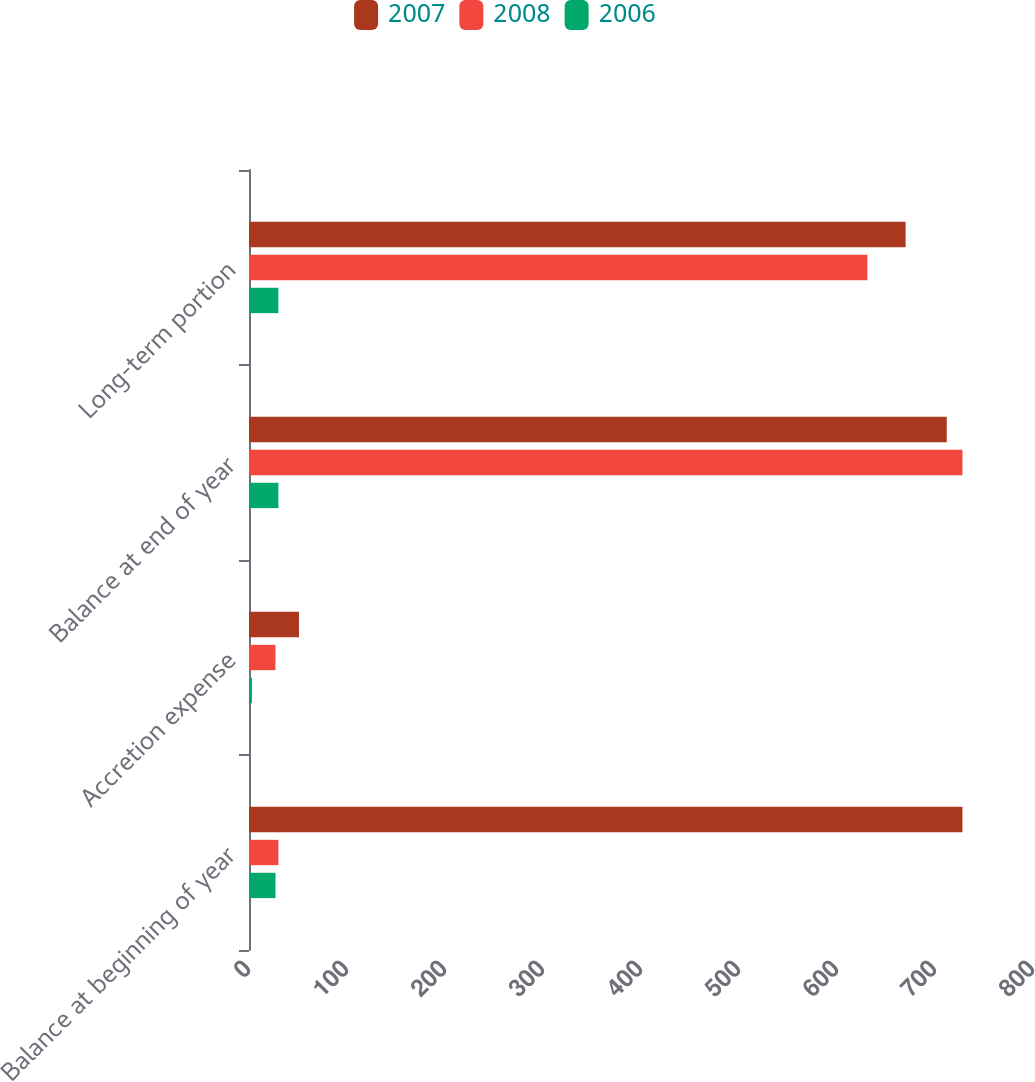<chart> <loc_0><loc_0><loc_500><loc_500><stacked_bar_chart><ecel><fcel>Balance at beginning of year<fcel>Accretion expense<fcel>Balance at end of year<fcel>Long-term portion<nl><fcel>2007<fcel>728<fcel>51<fcel>712<fcel>670<nl><fcel>2008<fcel>30<fcel>27<fcel>728<fcel>631<nl><fcel>2006<fcel>27<fcel>3<fcel>30<fcel>30<nl></chart> 